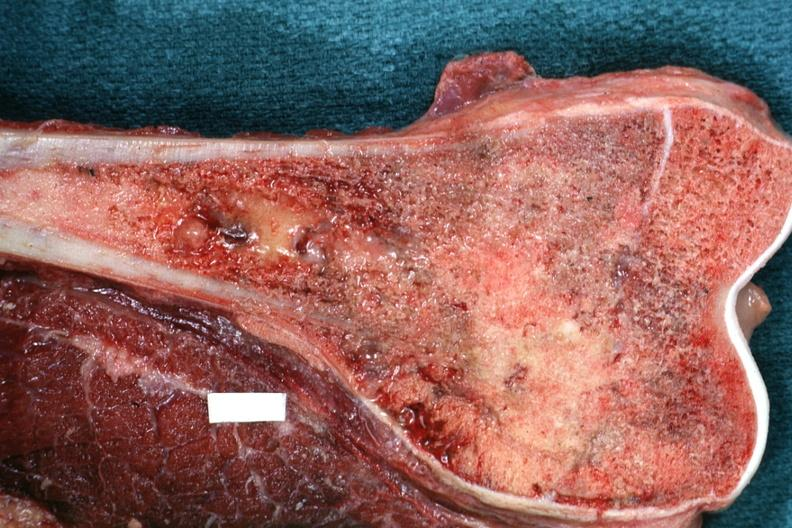what is sectioned femur lesion excellent example?
Answer the question using a single word or phrase. Distal end 